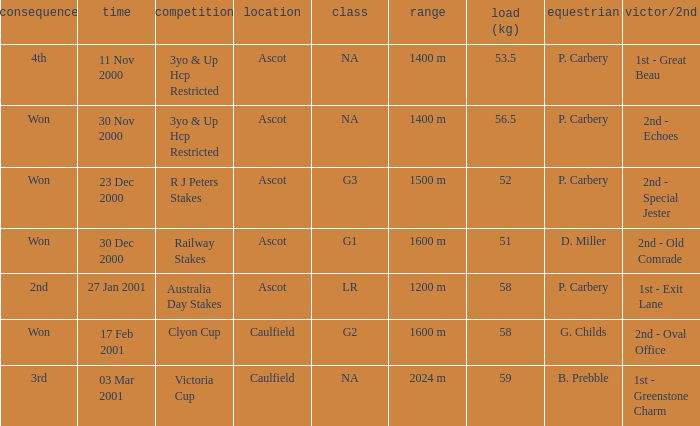What information can be found for the group with a 56.5 kg weight? NA. 